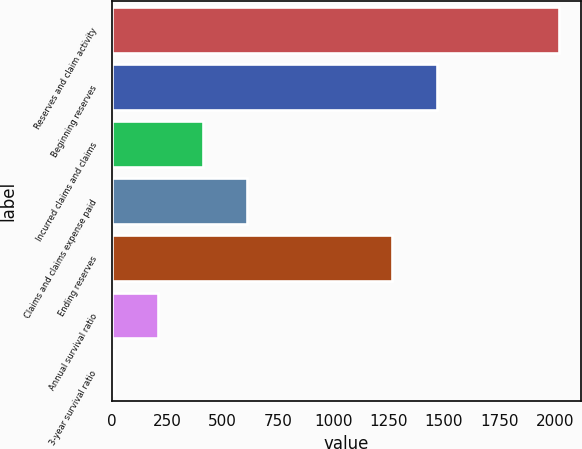Convert chart to OTSL. <chart><loc_0><loc_0><loc_500><loc_500><bar_chart><fcel>Reserves and claim activity<fcel>Beginning reserves<fcel>Incurred claims and claims<fcel>Claims and claims expense paid<fcel>Ending reserves<fcel>Annual survival ratio<fcel>3-year survival ratio<nl><fcel>2018<fcel>1466.89<fcel>410.88<fcel>611.77<fcel>1266<fcel>209.99<fcel>9.1<nl></chart> 